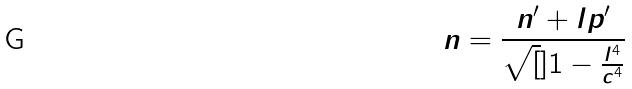<formula> <loc_0><loc_0><loc_500><loc_500>n = \frac { n ^ { \prime } + l p ^ { \prime } } { \sqrt { [ } ] { 1 - \frac { l ^ { 4 } } { c ^ { 4 } } } }</formula> 